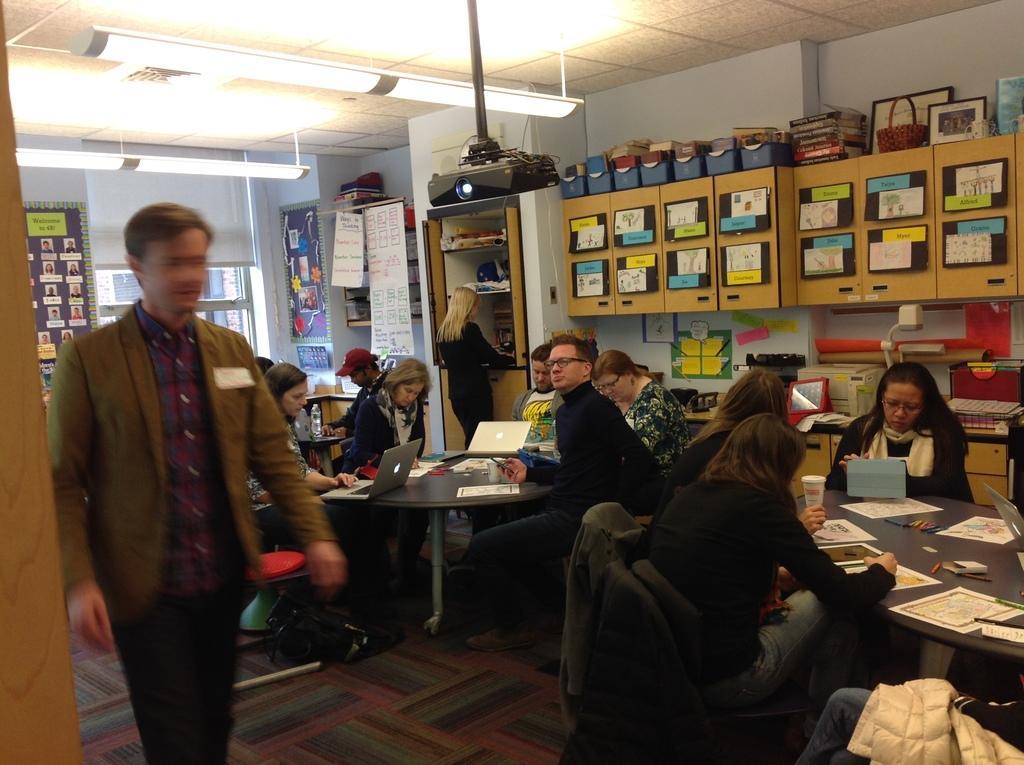Could you give a brief overview of what you see in this image? In this image we can see people are sitting on the chairs and there are two persons standing on the floor. Here we can see tables, papers, laptops, cupboards, posters, frames, books, lights, and few objects. In the background we can see wall and ceiling. 